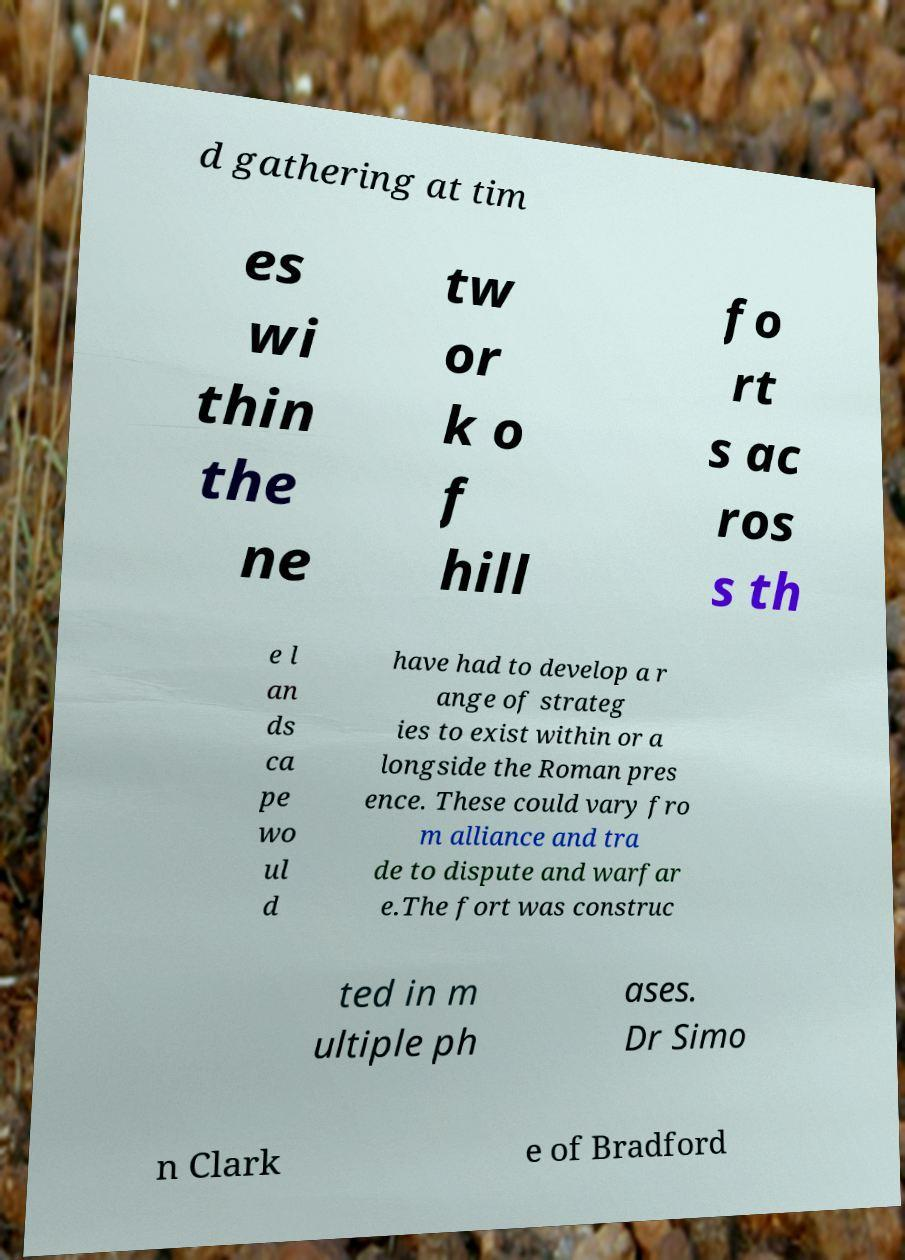For documentation purposes, I need the text within this image transcribed. Could you provide that? d gathering at tim es wi thin the ne tw or k o f hill fo rt s ac ros s th e l an ds ca pe wo ul d have had to develop a r ange of strateg ies to exist within or a longside the Roman pres ence. These could vary fro m alliance and tra de to dispute and warfar e.The fort was construc ted in m ultiple ph ases. Dr Simo n Clark e of Bradford 